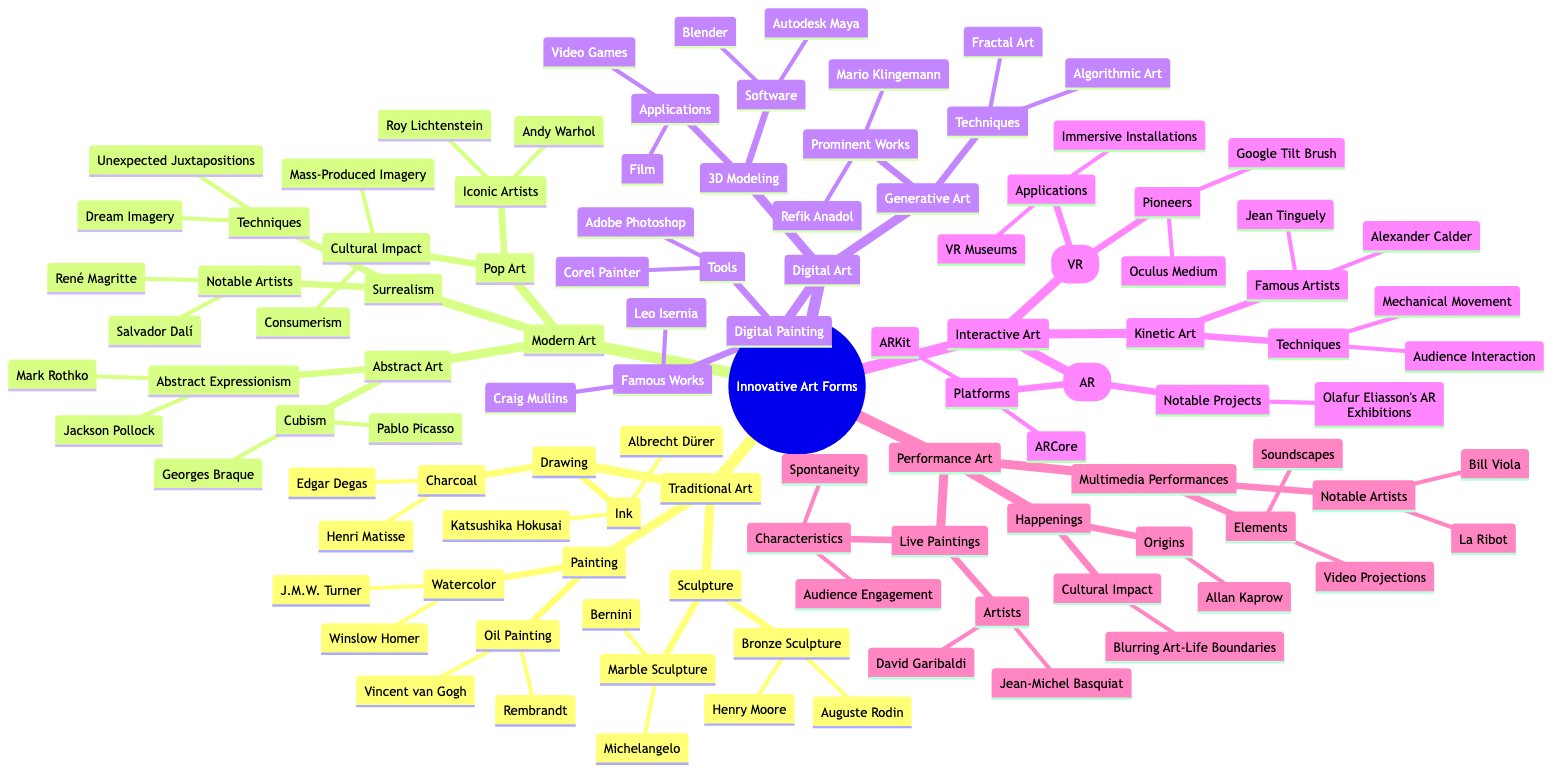What are the two techniques used in Surrealism? The diagram indicates "Dream Imagery" and "Unexpected Juxtapositions" as the two techniques associated with Surrealism under Modern Art.
Answer: Dream Imagery, Unexpected Juxtapositions Who are the famous artists in Digital Painting? According to the diagram, the famous works in Digital Painting are attributed to "Craig Mullins" and "Leo Isernia."
Answer: Craig Mullins, Leo Isernia How many forms of Interactive Art are listed? The diagram shows three forms of Interactive Art: Augmented Reality, Virtual Reality, and Kinetic Art, thus the count is three.
Answer: 3 What is the origin of Happenings in Performance Art? The diagram specifies "Allan Kaprow" as the origin of Happenings under Performance Art, which points to his foundational role in this art form.
Answer: Allan Kaprow Which artist is associated with Oil Painting? The diagram lists "Vincent van Gogh" and "Rembrandt" under the category of Oil Painting in Traditional Art, thus identifying these two artists with this medium.
Answer: Vincent van Gogh, Rembrandt What techniques are used in Kinetic Art? The diagram describes Kinetic Art employing "Mechanical Movement" and "Audience Interaction" as its techniques, indicating the dynamic nature of this form.
Answer: Mechanical Movement, Audience Interaction What notable projects are associated with Augmented Reality? The diagram highlights "Olafur Eliasson’s AR Exhibitions" as a notable project within the field of Augmented Reality, emphasizing its significance in contemporary art.
Answer: Olafur Eliasson’s AR Exhibitions Which software is used for 3D Modeling? According to the diagram, "Autodesk Maya" and "Blender" are listed as the software used for 3D Modeling, indicating their importance in the field.
Answer: Autodesk Maya, Blender What type of art employs video projections and soundscapes? The diagram categorizes "Multimedia Performances" under Performance Art, specifying that these elements are integral to this art form.
Answer: Multimedia Performances 